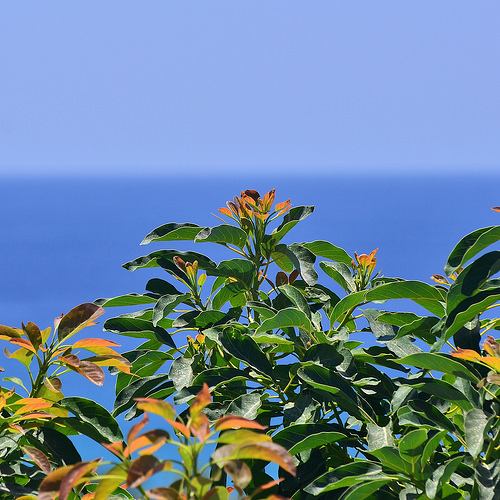<image>
Can you confirm if the plant is in front of the sea? Yes. The plant is positioned in front of the sea, appearing closer to the camera viewpoint. 